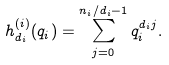<formula> <loc_0><loc_0><loc_500><loc_500>h _ { d _ { i } } ^ { ( i ) } ( q _ { i } ) = \sum _ { j = 0 } ^ { n _ { i } / d _ { i } - 1 } q _ { i } ^ { d _ { i } j } .</formula> 